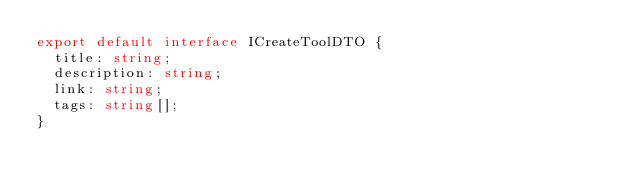<code> <loc_0><loc_0><loc_500><loc_500><_TypeScript_>export default interface ICreateToolDTO {
  title: string;
  description: string;
  link: string;
  tags: string[];
}
</code> 